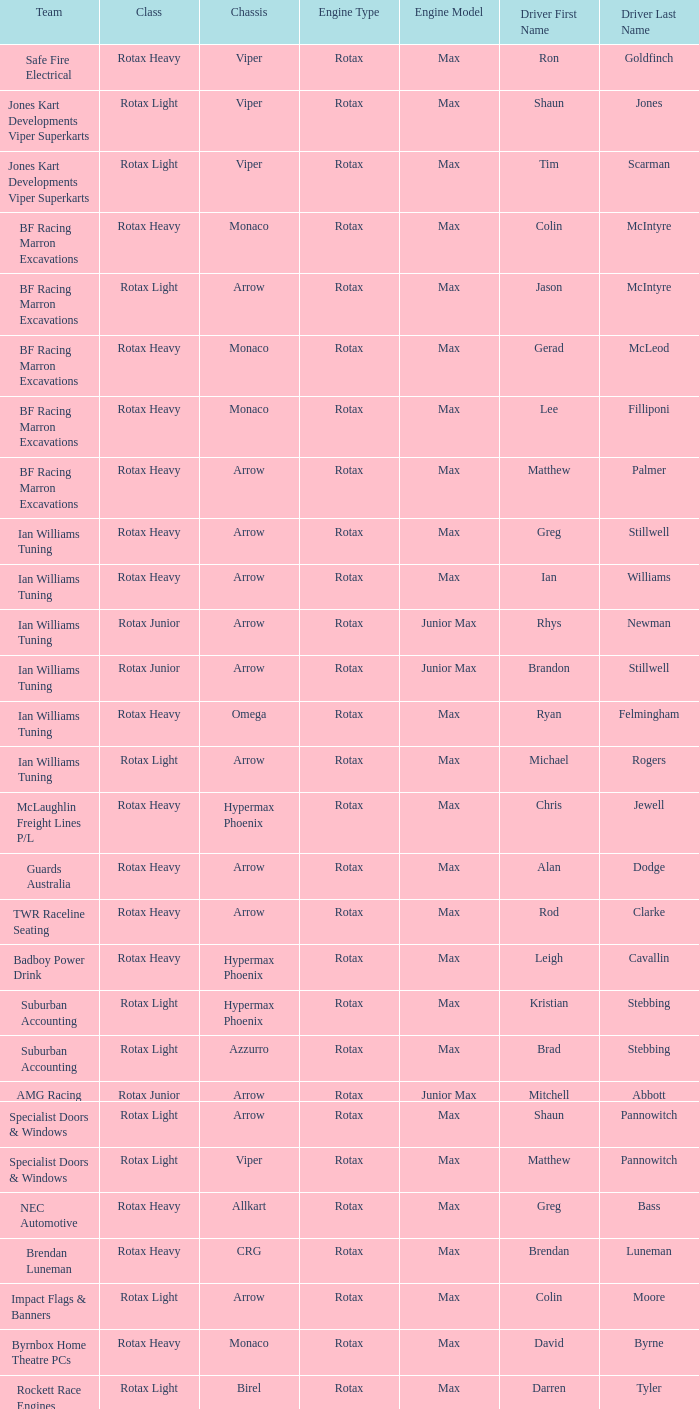What type of engine does the BF Racing Marron Excavations have that also has Monaco as chassis and Lee Filliponi as the driver? Rotax Max. Could you help me parse every detail presented in this table? {'header': ['Team', 'Class', 'Chassis', 'Engine Type', 'Engine Model', 'Driver First Name', 'Driver Last Name'], 'rows': [['Safe Fire Electrical', 'Rotax Heavy', 'Viper', 'Rotax', 'Max', 'Ron', 'Goldfinch'], ['Jones Kart Developments Viper Superkarts', 'Rotax Light', 'Viper', 'Rotax', 'Max', 'Shaun', 'Jones'], ['Jones Kart Developments Viper Superkarts', 'Rotax Light', 'Viper', 'Rotax', 'Max', 'Tim', 'Scarman'], ['BF Racing Marron Excavations', 'Rotax Heavy', 'Monaco', 'Rotax', 'Max', 'Colin', 'McIntyre'], ['BF Racing Marron Excavations', 'Rotax Light', 'Arrow', 'Rotax', 'Max', 'Jason', 'McIntyre'], ['BF Racing Marron Excavations', 'Rotax Heavy', 'Monaco', 'Rotax', 'Max', 'Gerad', 'McLeod'], ['BF Racing Marron Excavations', 'Rotax Heavy', 'Monaco', 'Rotax', 'Max', 'Lee', 'Filliponi'], ['BF Racing Marron Excavations', 'Rotax Heavy', 'Arrow', 'Rotax', 'Max', 'Matthew', 'Palmer'], ['Ian Williams Tuning', 'Rotax Heavy', 'Arrow', 'Rotax', 'Max', 'Greg', 'Stillwell'], ['Ian Williams Tuning', 'Rotax Heavy', 'Arrow', 'Rotax', 'Max', 'Ian', 'Williams'], ['Ian Williams Tuning', 'Rotax Junior', 'Arrow', 'Rotax', 'Junior Max', 'Rhys', 'Newman'], ['Ian Williams Tuning', 'Rotax Junior', 'Arrow', 'Rotax', 'Junior Max', 'Brandon', 'Stillwell'], ['Ian Williams Tuning', 'Rotax Heavy', 'Omega', 'Rotax', 'Max', 'Ryan', 'Felmingham'], ['Ian Williams Tuning', 'Rotax Light', 'Arrow', 'Rotax', 'Max', 'Michael', 'Rogers'], ['McLaughlin Freight Lines P/L', 'Rotax Heavy', 'Hypermax Phoenix', 'Rotax', 'Max', 'Chris', 'Jewell'], ['Guards Australia', 'Rotax Heavy', 'Arrow', 'Rotax', 'Max', 'Alan', 'Dodge'], ['TWR Raceline Seating', 'Rotax Heavy', 'Arrow', 'Rotax', 'Max', 'Rod', 'Clarke'], ['Badboy Power Drink', 'Rotax Heavy', 'Hypermax Phoenix', 'Rotax', 'Max', 'Leigh', 'Cavallin'], ['Suburban Accounting', 'Rotax Light', 'Hypermax Phoenix', 'Rotax', 'Max', 'Kristian', 'Stebbing'], ['Suburban Accounting', 'Rotax Light', 'Azzurro', 'Rotax', 'Max', 'Brad', 'Stebbing'], ['AMG Racing', 'Rotax Junior', 'Arrow', 'Rotax', 'Junior Max', 'Mitchell', 'Abbott'], ['Specialist Doors & Windows', 'Rotax Light', 'Arrow', 'Rotax', 'Max', 'Shaun', 'Pannowitch'], ['Specialist Doors & Windows', 'Rotax Light', 'Viper', 'Rotax', 'Max', 'Matthew', 'Pannowitch'], ['NEC Automotive', 'Rotax Heavy', 'Allkart', 'Rotax', 'Max', 'Greg', 'Bass'], ['Brendan Luneman', 'Rotax Heavy', 'CRG', 'Rotax', 'Max', 'Brendan', 'Luneman'], ['Impact Flags & Banners', 'Rotax Light', 'Arrow', 'Rotax', 'Max', 'Colin', 'Moore'], ['Byrnbox Home Theatre PCs', 'Rotax Heavy', 'Monaco', 'Rotax', 'Max', 'David', 'Byrne'], ['Rockett Race Engines', 'Rotax Light', 'Birel', 'Rotax', 'Max', 'Darren', 'Tyler'], ['Racecentre', 'Rotax Junior', 'Arrow', 'Rotax', 'Junior Max', 'David', 'Webster'], ['Racecentre', 'Rotax Light', 'Arrow', 'Rotax', 'Max', 'Peter', 'Strangis'], ['www.kartsportnews.com', 'Rotax Heavy', 'Hypermax Phoenix', 'Rotax', 'Max', 'Mark', 'Wicks'], ['Doug Savage', 'Rotax Light', 'Arrow', 'Rotax', 'Max', 'Doug', 'Savage'], ['Race Stickerz Toyota Material Handling', 'Rotax Heavy', 'Techno', 'Rotax', 'Max', 'Scott', 'Appledore'], ['Wild Digital', 'Rotax Junior', 'Hypermax Phoenix', 'Rotax', 'Junior Max', 'Sean', 'Whitfield'], ['John Bartlett', 'Rotax Heavy', 'Hypermax Phoenix', 'Rotax', 'Max', 'John', 'Bartlett']]} 